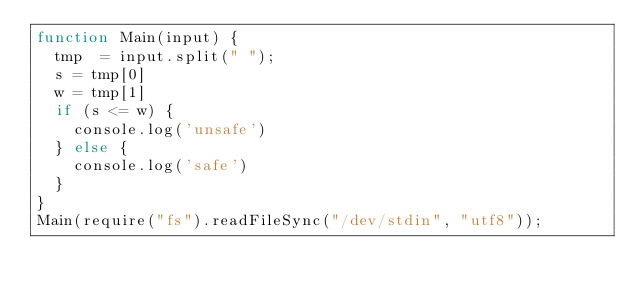Convert code to text. <code><loc_0><loc_0><loc_500><loc_500><_JavaScript_>function Main(input) {
	tmp  = input.split(" ");
	s = tmp[0]
	w = tmp[1]
  if (s <= w) {
  	console.log('unsafe')
  } else {
  	console.log('safe')
  }
}
Main(require("fs").readFileSync("/dev/stdin", "utf8"));</code> 